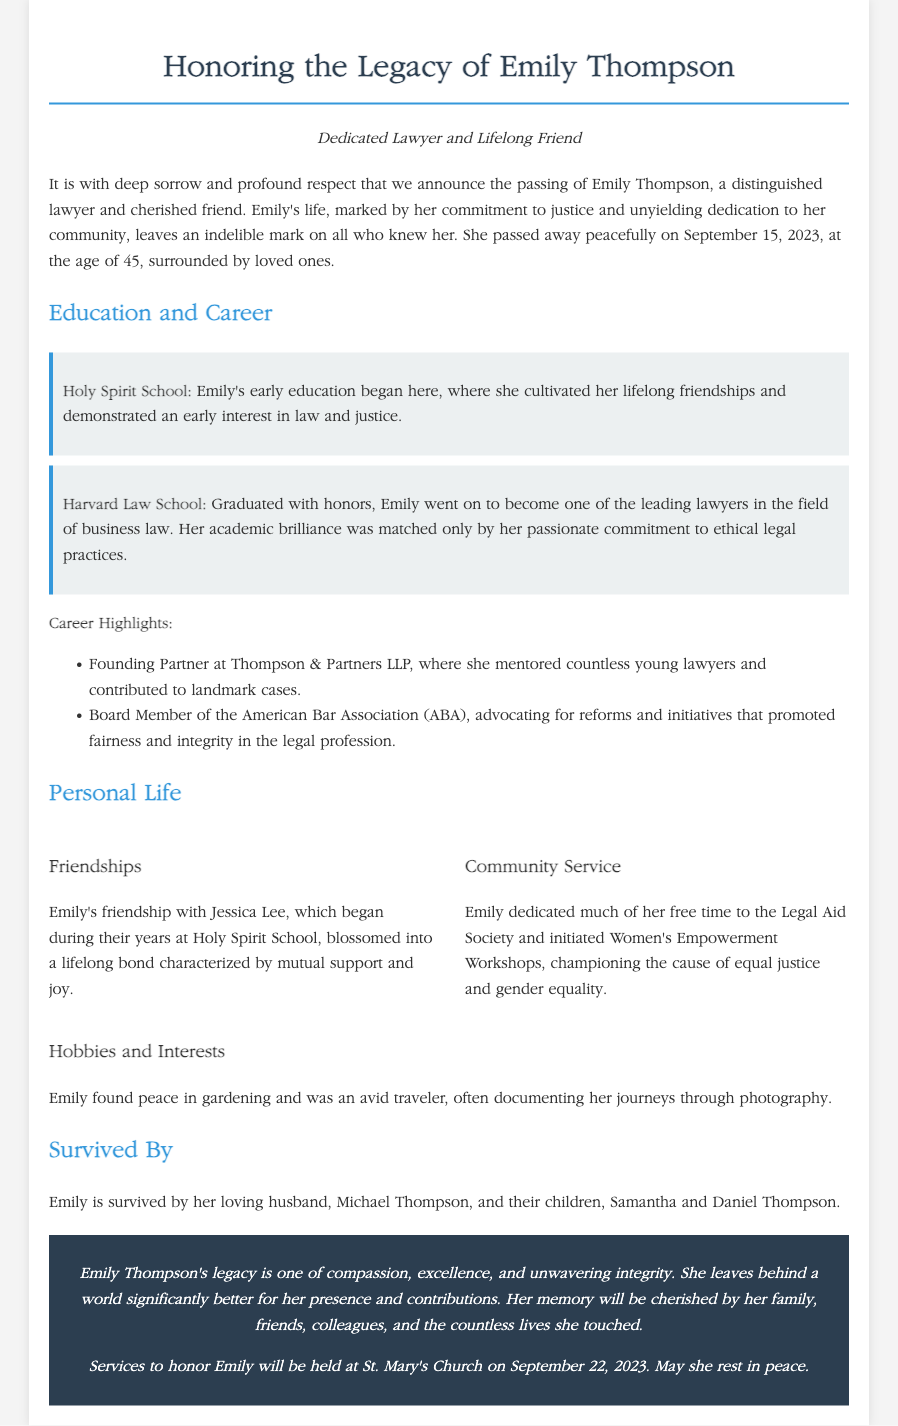What date did Emily Thompson pass away? The document states that Emily Thompson passed away on September 15, 2023.
Answer: September 15, 2023 Where did Emily receive her early education? The document mentions that Emily's early education began at Holy Spirit School.
Answer: Holy Spirit School What profession did Emily Thompson specialize in? The document describes Emily as a distinguished lawyer specializing in business law.
Answer: Business law Who was Emily's best friend mentioned in the document? The obituary highlights Emily's friendship with Jessica Lee, which started in school.
Answer: Jessica Lee What organization did Emily serve as a board member? The document notes that Emily was a board member of the American Bar Association (ABA).
Answer: American Bar Association How many children did Emily have? The document indicates that Emily is survived by her two children, Samantha and Daniel.
Answer: Two What community service initiative did Emily initiate? The document mentions that Emily initiated Women's Empowerment Workshops.
Answer: Women's Empowerment Workshops What was the location of Emily's memorial services? The document states that services to honor Emily will be held at St. Mary's Church.
Answer: St. Mary's Church At what age did Emily pass away? The document specifies that Emily was 45 years old at the time of her passing.
Answer: 45 